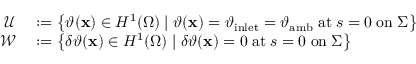Convert formula to latex. <formula><loc_0><loc_0><loc_500><loc_500>\begin{array} { r l } { \mathcal { U } } & \colon = \left \{ \vartheta ( x ) \in H ^ { 1 } ( \Omega ) \, | \, \vartheta ( x ) = \vartheta _ { i n l e t } = \vartheta _ { a m b } \, a t \, s = 0 \, o n \, \Sigma \right \} } \\ { \mathcal { W } } & \colon = \left \{ \delta \vartheta ( x ) \in H ^ { 1 } ( \Omega ) \, | \, \delta \vartheta ( x ) = 0 \, a t \, s = 0 \, o n \, \Sigma \right \} } \end{array}</formula> 